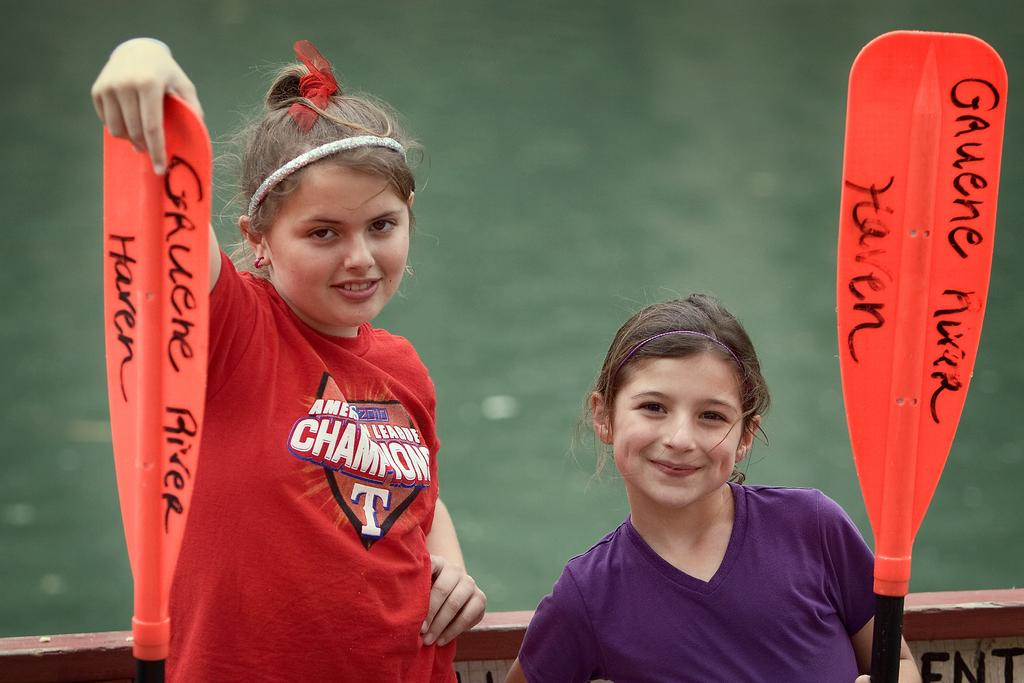<image>
Summarize the visual content of the image. Two girls are holding up orange oars that read Gruene River Haren 